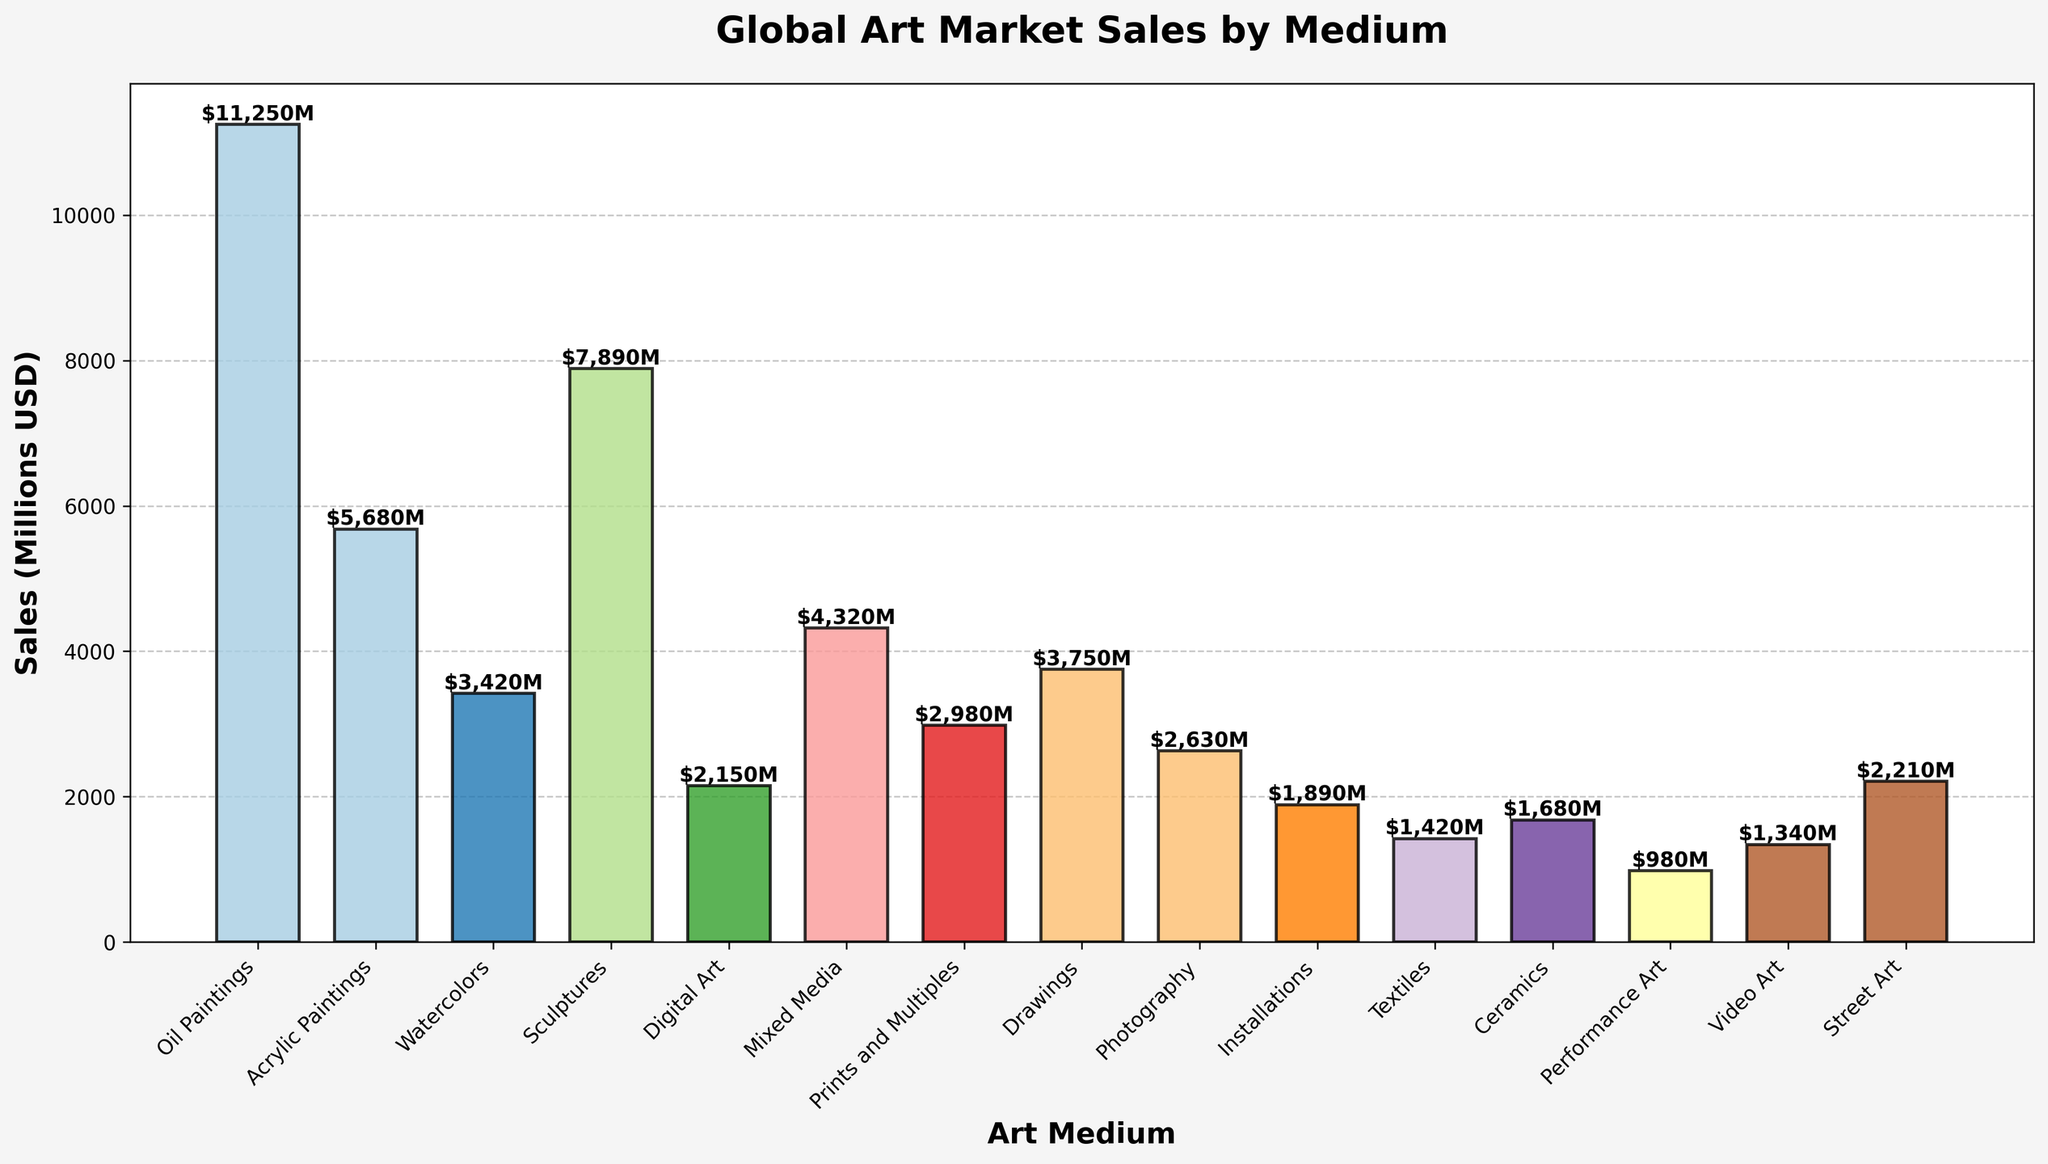How much are the total sales for medium categories exceeding $5000 million? Identify the bars with sales over $5000 million (Oil Paintings and Acrylic Paintings). Sum their sales: 11250 + 5680 = 16930
Answer: $16930 million Which art medium has the highest sales? Identify the bar with the highest height. The one representing Oil Paintings is the tallest with sales of $11250 million.
Answer: Oil Paintings What is the average sales value for Digital Art, Photography, and Installations? Sum the sales for Digital Art, Photography, and Installations: 2150 + 2630 + 1890 = 6670. Divide by the number of categories: 6670 / 3 = 2223.33
Answer: $2223.33 million Are the sales of Sculptures greater than the combined sales of Ceramics and Textiles? Compare the sales of Sculptures (7890) with the combined sales of Ceramics (1680) and Textiles (1420): 1680 + 1420 = 3100. 7890 > 3100.
Answer: Yes Which medium shows the lowest sales figure? Identify the bar with the shortest height, which represents Performance Art with sales of $980 million.
Answer: Performance Art How much more are the sales for Oil Paintings compared to Acrylic Paintings? Subtract the sales of Acrylic Paintings (5680) from Oil Paintings (11250): 11250 - 5680 = 5570
Answer: $5570 million What is the difference in sales between the highest and lowest selling mediums? Subtract the sales of Performance Art (lowest at $980 million) from Oil Paintings (highest at $11250 million): 11250 - 980 = 10270
Answer: $10270 million What is the combined sales figure for mixed media categories (Mixed Media, Prints and Multiples, and Street Art)? Sum the sales for Mixed Media (4320), Prints and Multiples (2980), and Street Art (2210): 4320 + 2980 + 2210 = 9510
Answer: $9510 million Which art medium has sales closest to $3000 million? Identify the sales figures and find the closest to $3000 million. Prints and Multiples have $2980 million, closest to $3000 million.
Answer: Prints and Multiples 